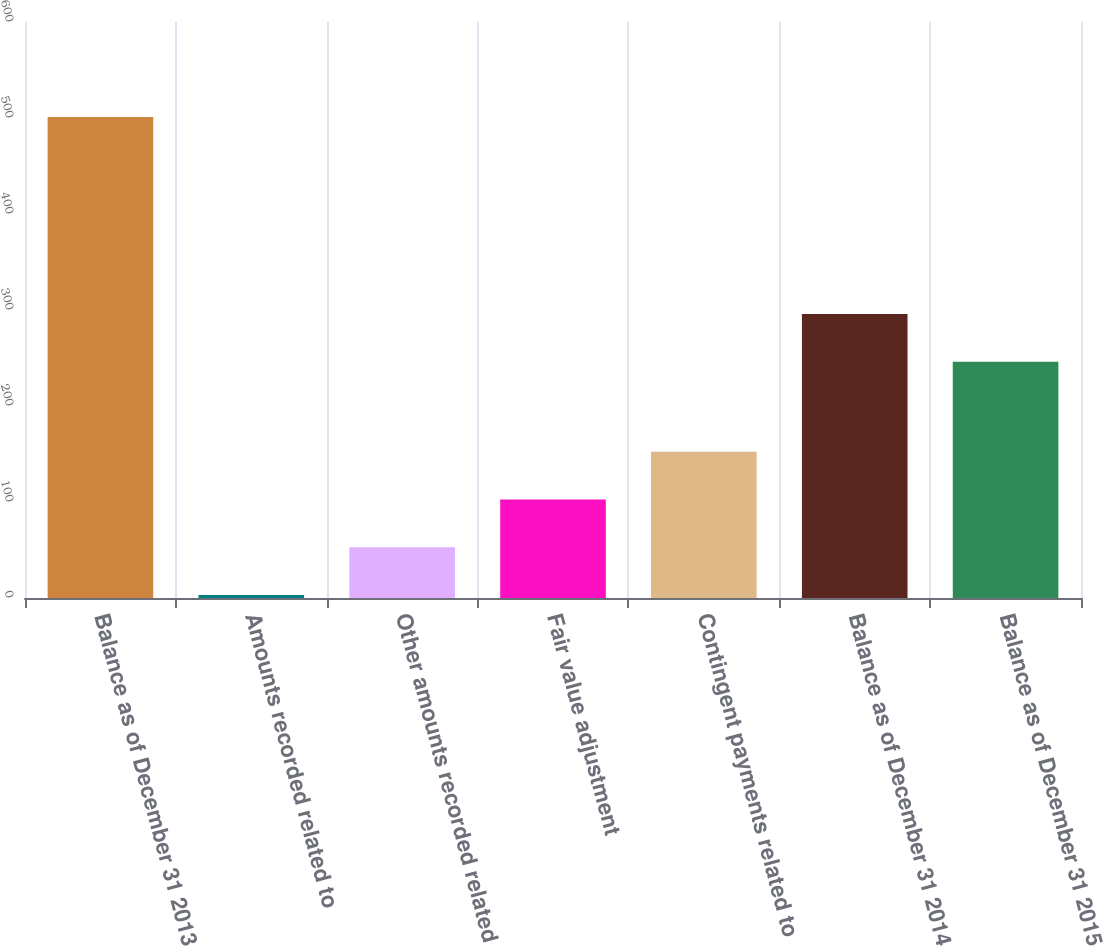Convert chart to OTSL. <chart><loc_0><loc_0><loc_500><loc_500><bar_chart><fcel>Balance as of December 31 2013<fcel>Amounts recorded related to<fcel>Other amounts recorded related<fcel>Fair value adjustment<fcel>Contingent payments related to<fcel>Balance as of December 31 2014<fcel>Balance as of December 31 2015<nl><fcel>501<fcel>3<fcel>52.8<fcel>102.6<fcel>152.4<fcel>295.8<fcel>246<nl></chart> 